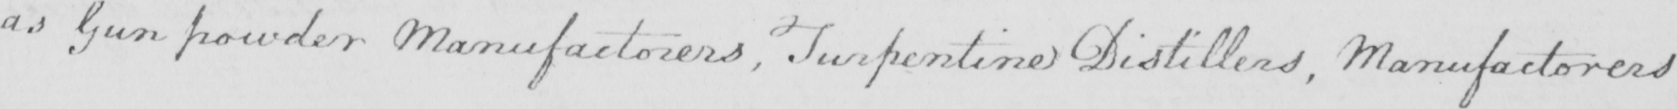What does this handwritten line say? as Gun powder Manufactorers, Turpentine Distillers, Manufactorers 